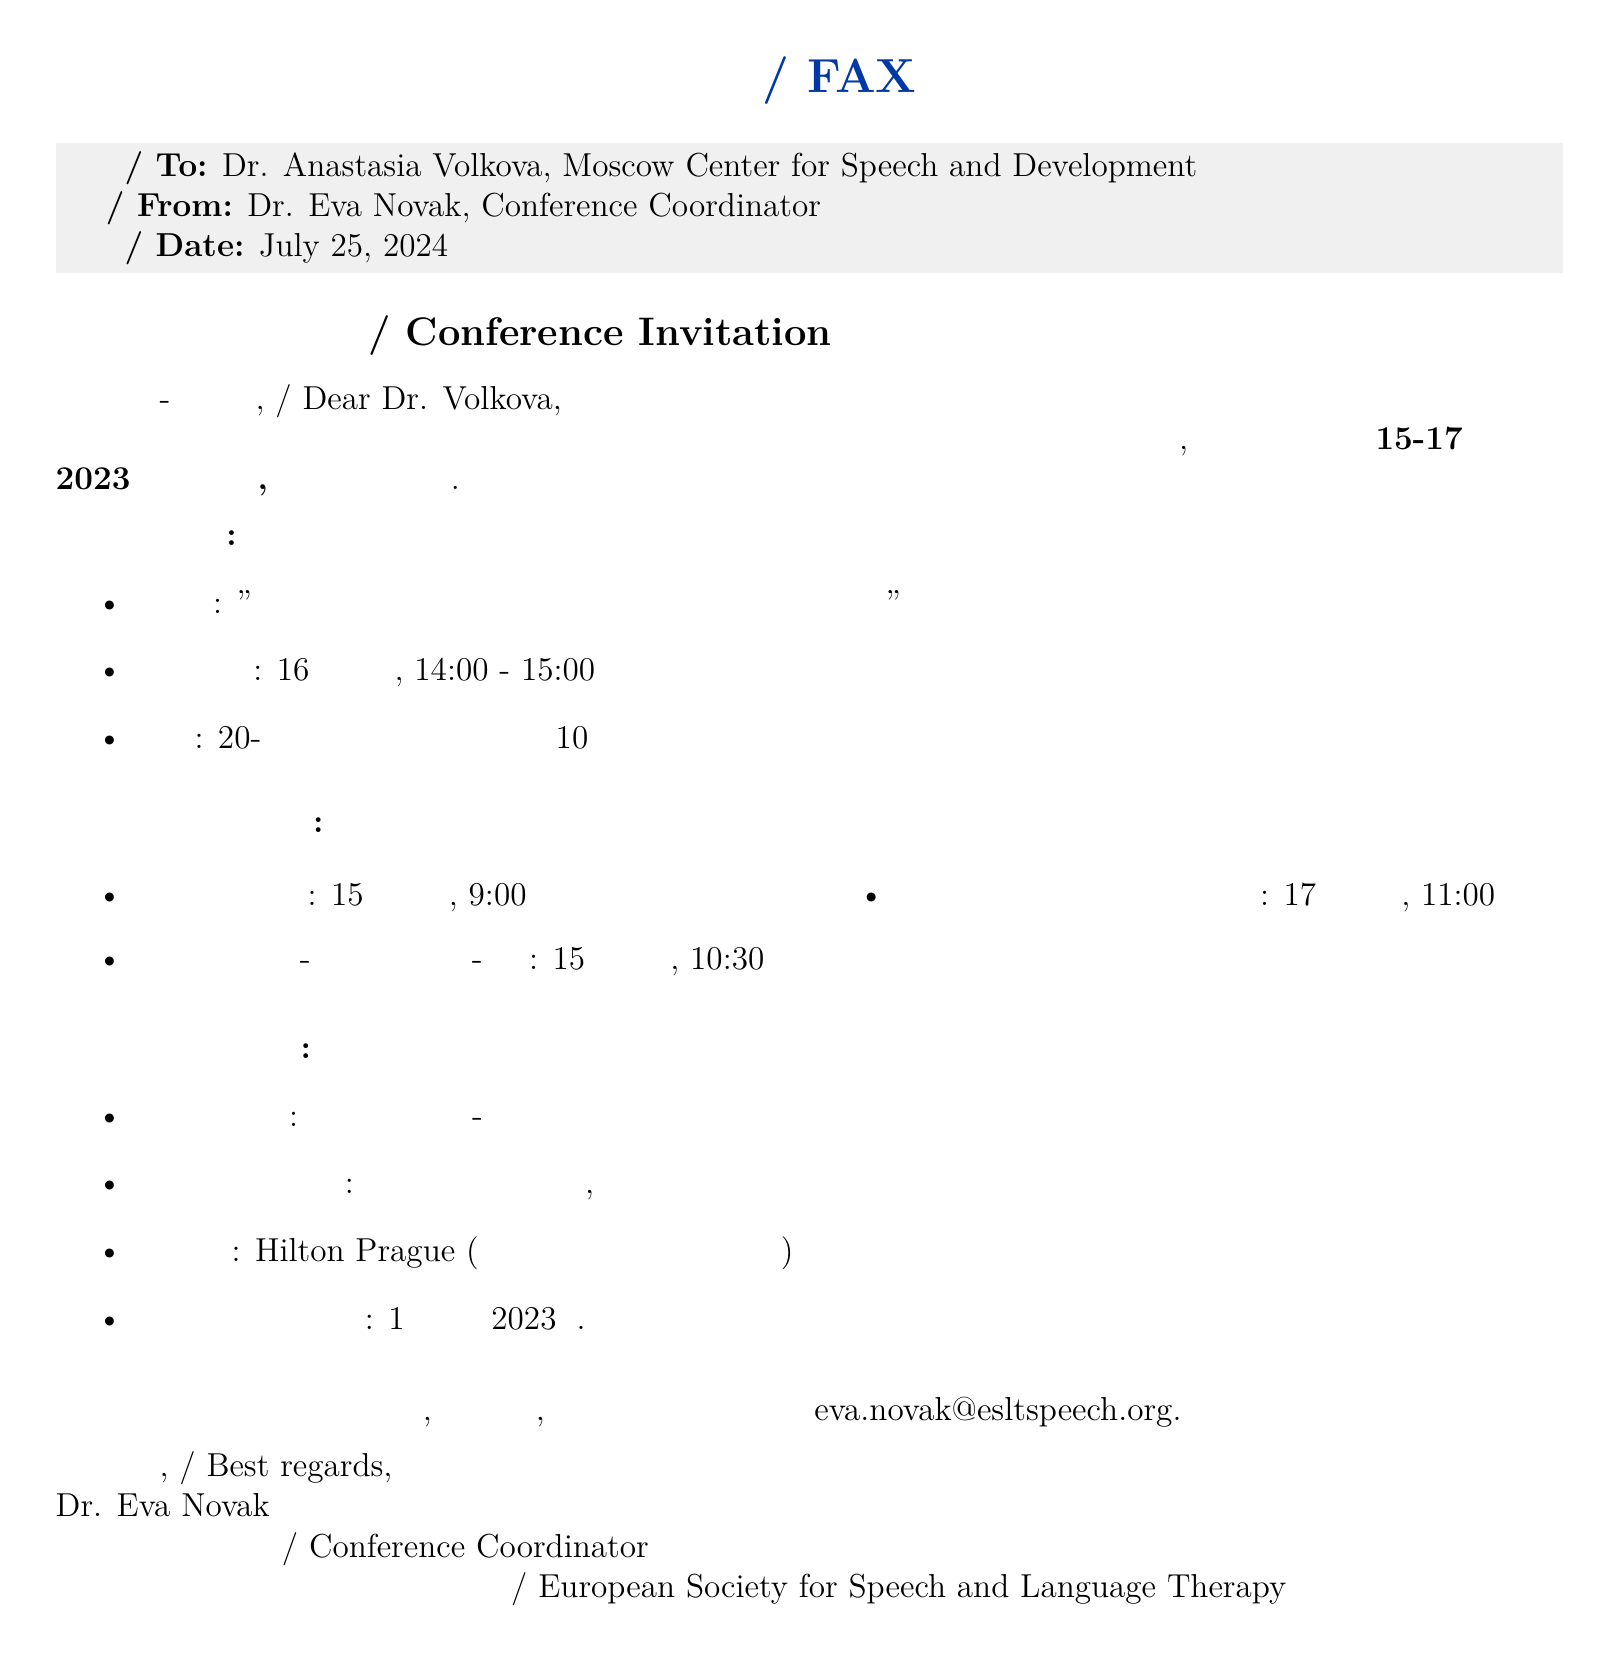what is the date of the conference? The conference will be held from September 15 to September 17, 2023.
Answer: 15-17 сентября 2023 года who is the keynote speaker? The keynote speaker mentioned in the document is Dr. Simon Baron-Cohen.
Answer: д-р Саймон Барон-Коэн where is the conference taking place? The event location listed is the Prague Congress Center.
Answer: Пражский конгресс-центр what is the title of the presentation? The title of the presentation is "Adaptive Communication Strategies for Nonverbal Children with Autism."
Answer: "Адаптивные стратегии коммуникации для невербальных детей с аутизмом" when is the deadline for registration? The registration deadline provided in the document is August 1, 2023.
Answer: 1 августа 2023 г what is the format of the presentation? The presentation format is a 20-minute talk followed by 10 minutes for questions.
Answer: 20-минутный доклад с последующими 10 минутами для вопросов и ответов which airport is recommended for travel? The recommended airport for the conference is Václav Havel Airport, Prague.
Answer: Аэропорт Вацлава Гавела, Прага who is the sender of the fax? The sender of the fax is Dr. Eva Novak, the Conference Coordinator.
Answer: д-р Ева Новак 